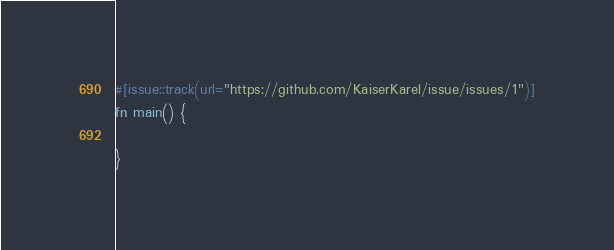Convert code to text. <code><loc_0><loc_0><loc_500><loc_500><_Rust_>

#[issue::track(url="https://github.com/KaiserKarel/issue/issues/1")]
fn main() {

}</code> 